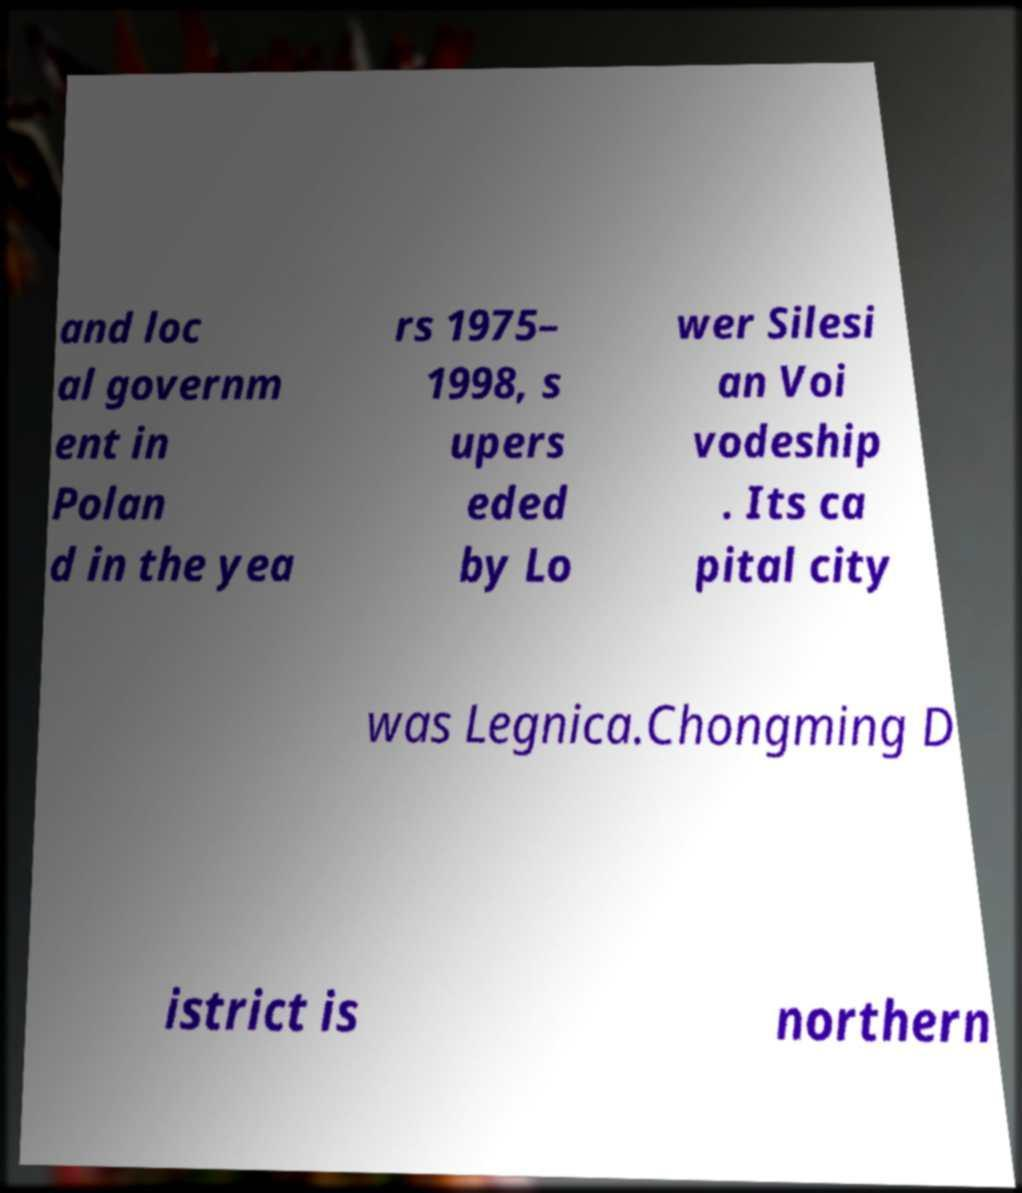There's text embedded in this image that I need extracted. Can you transcribe it verbatim? and loc al governm ent in Polan d in the yea rs 1975– 1998, s upers eded by Lo wer Silesi an Voi vodeship . Its ca pital city was Legnica.Chongming D istrict is northern 